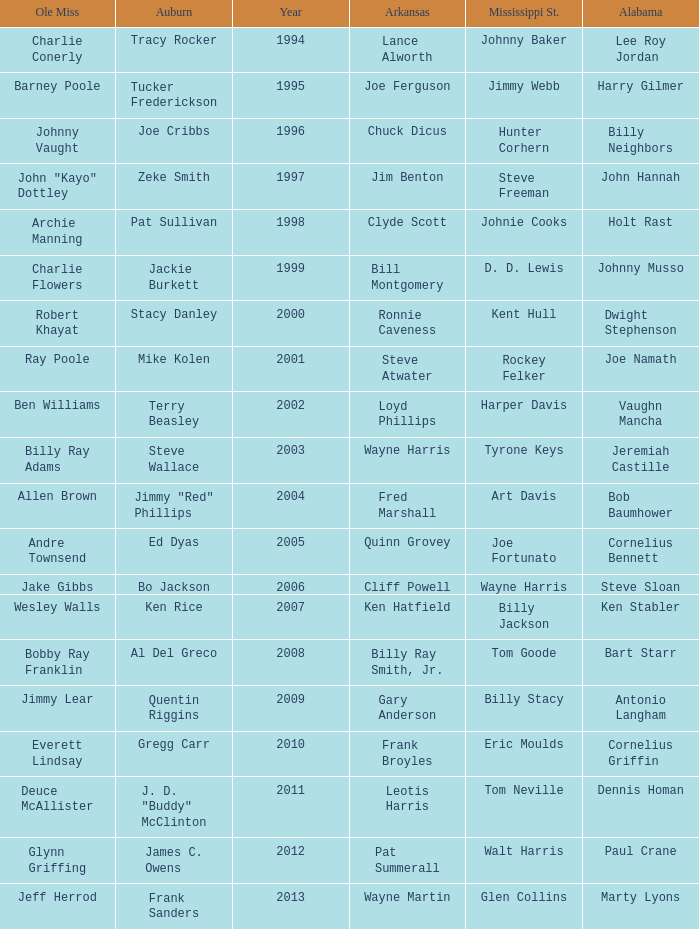Who was the Ole Miss player associated with Chuck Dicus? Johnny Vaught. 